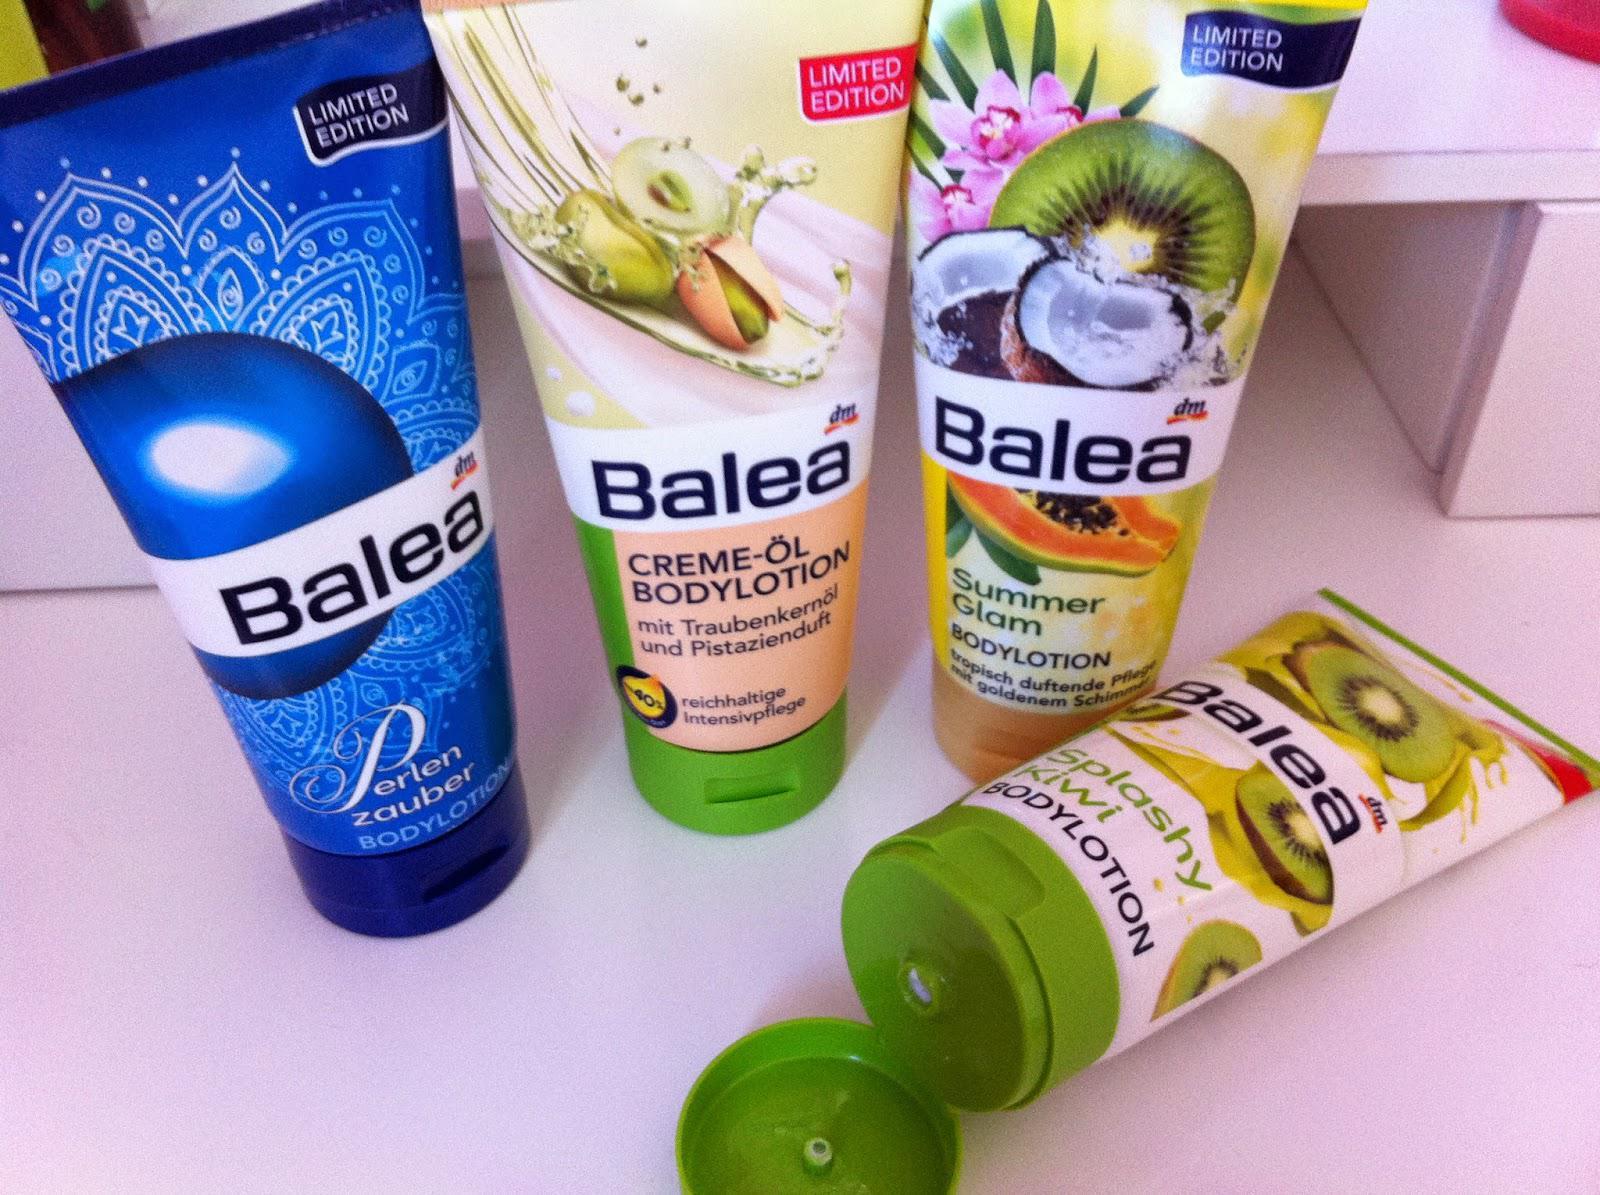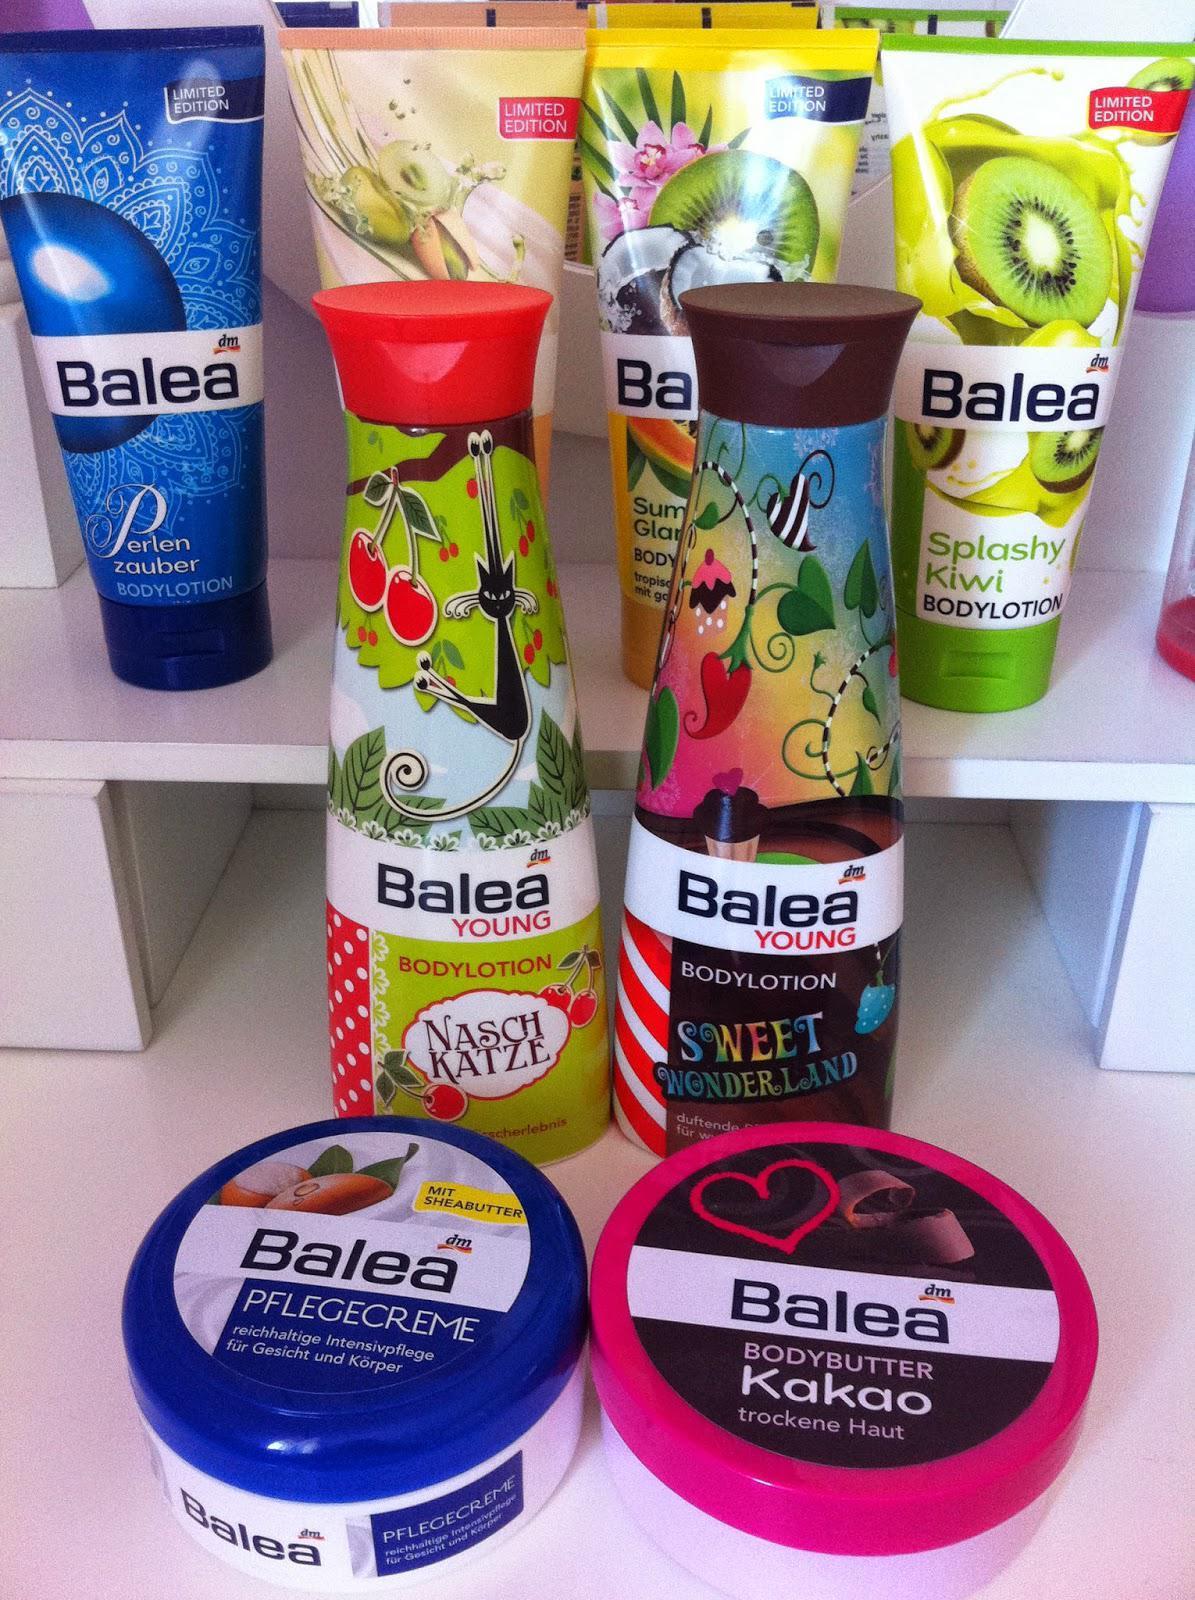The first image is the image on the left, the second image is the image on the right. Evaluate the accuracy of this statement regarding the images: "The image on the right contains both a blue and a red circular container.". Is it true? Answer yes or no. Yes. 